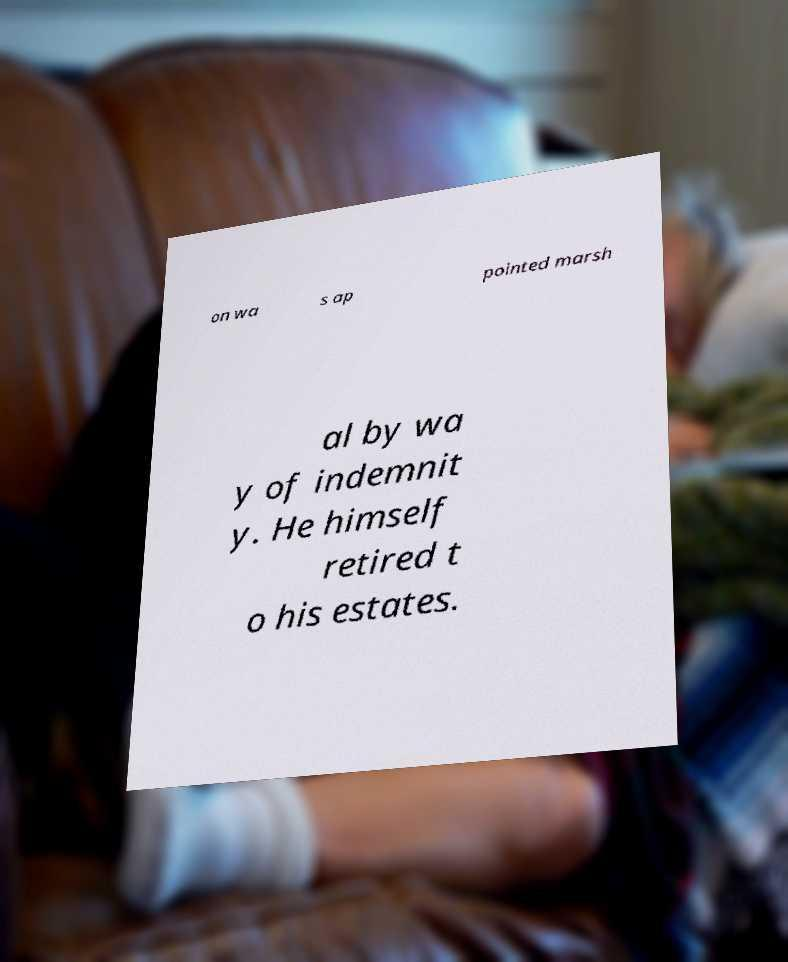Can you read and provide the text displayed in the image?This photo seems to have some interesting text. Can you extract and type it out for me? on wa s ap pointed marsh al by wa y of indemnit y. He himself retired t o his estates. 